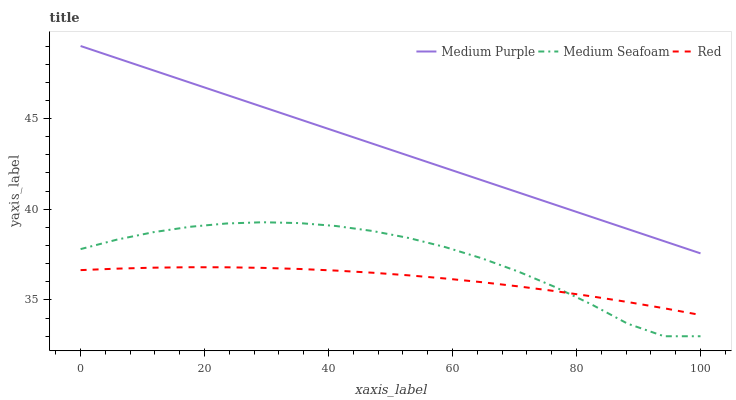Does Red have the minimum area under the curve?
Answer yes or no. Yes. Does Medium Purple have the maximum area under the curve?
Answer yes or no. Yes. Does Medium Seafoam have the minimum area under the curve?
Answer yes or no. No. Does Medium Seafoam have the maximum area under the curve?
Answer yes or no. No. Is Medium Purple the smoothest?
Answer yes or no. Yes. Is Medium Seafoam the roughest?
Answer yes or no. Yes. Is Red the smoothest?
Answer yes or no. No. Is Red the roughest?
Answer yes or no. No. Does Medium Seafoam have the lowest value?
Answer yes or no. Yes. Does Red have the lowest value?
Answer yes or no. No. Does Medium Purple have the highest value?
Answer yes or no. Yes. Does Medium Seafoam have the highest value?
Answer yes or no. No. Is Medium Seafoam less than Medium Purple?
Answer yes or no. Yes. Is Medium Purple greater than Red?
Answer yes or no. Yes. Does Medium Seafoam intersect Red?
Answer yes or no. Yes. Is Medium Seafoam less than Red?
Answer yes or no. No. Is Medium Seafoam greater than Red?
Answer yes or no. No. Does Medium Seafoam intersect Medium Purple?
Answer yes or no. No. 